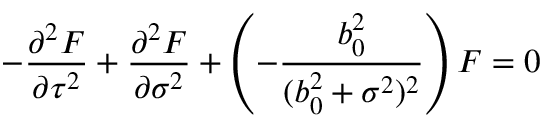Convert formula to latex. <formula><loc_0><loc_0><loc_500><loc_500>- \frac { { \partial } ^ { 2 } F } { { \partial } \tau ^ { 2 } } + \frac { { \partial } ^ { 2 } F } { { \partial } \sigma ^ { 2 } } + \left ( - \frac { b _ { 0 } ^ { 2 } } { ( b _ { 0 } ^ { 2 } + \sigma ^ { 2 } ) ^ { 2 } } \right ) F = 0</formula> 